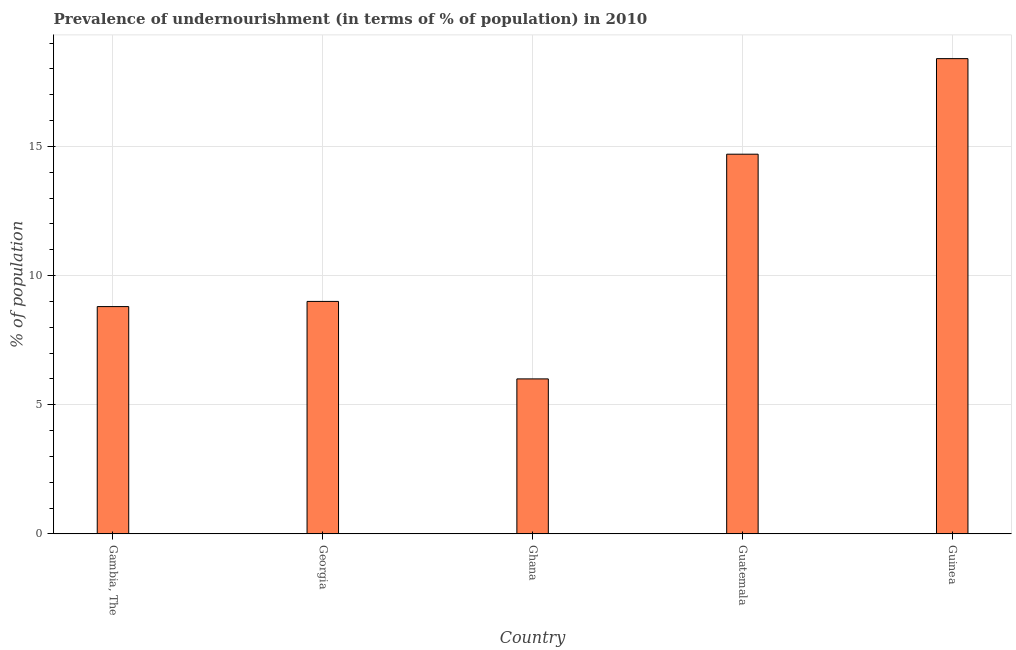Does the graph contain any zero values?
Provide a succinct answer. No. What is the title of the graph?
Offer a very short reply. Prevalence of undernourishment (in terms of % of population) in 2010. What is the label or title of the Y-axis?
Provide a succinct answer. % of population. Across all countries, what is the minimum percentage of undernourished population?
Make the answer very short. 6. In which country was the percentage of undernourished population maximum?
Your answer should be very brief. Guinea. What is the sum of the percentage of undernourished population?
Your answer should be compact. 56.9. What is the difference between the percentage of undernourished population in Georgia and Guinea?
Keep it short and to the point. -9.4. What is the average percentage of undernourished population per country?
Keep it short and to the point. 11.38. What is the median percentage of undernourished population?
Your answer should be compact. 9. What is the ratio of the percentage of undernourished population in Gambia, The to that in Guatemala?
Ensure brevity in your answer.  0.6. Is the percentage of undernourished population in Ghana less than that in Guatemala?
Offer a very short reply. Yes. What is the difference between the highest and the second highest percentage of undernourished population?
Your answer should be compact. 3.7. How many bars are there?
Your response must be concise. 5. Are all the bars in the graph horizontal?
Make the answer very short. No. Are the values on the major ticks of Y-axis written in scientific E-notation?
Offer a terse response. No. What is the % of population in Ghana?
Offer a terse response. 6. What is the % of population in Guatemala?
Provide a short and direct response. 14.7. What is the % of population of Guinea?
Your response must be concise. 18.4. What is the difference between the % of population in Gambia, The and Guinea?
Your response must be concise. -9.6. What is the difference between the % of population in Georgia and Ghana?
Ensure brevity in your answer.  3. What is the difference between the % of population in Ghana and Guatemala?
Offer a very short reply. -8.7. What is the difference between the % of population in Guatemala and Guinea?
Make the answer very short. -3.7. What is the ratio of the % of population in Gambia, The to that in Ghana?
Your answer should be very brief. 1.47. What is the ratio of the % of population in Gambia, The to that in Guatemala?
Provide a succinct answer. 0.6. What is the ratio of the % of population in Gambia, The to that in Guinea?
Offer a terse response. 0.48. What is the ratio of the % of population in Georgia to that in Guatemala?
Ensure brevity in your answer.  0.61. What is the ratio of the % of population in Georgia to that in Guinea?
Your response must be concise. 0.49. What is the ratio of the % of population in Ghana to that in Guatemala?
Give a very brief answer. 0.41. What is the ratio of the % of population in Ghana to that in Guinea?
Keep it short and to the point. 0.33. What is the ratio of the % of population in Guatemala to that in Guinea?
Your answer should be very brief. 0.8. 